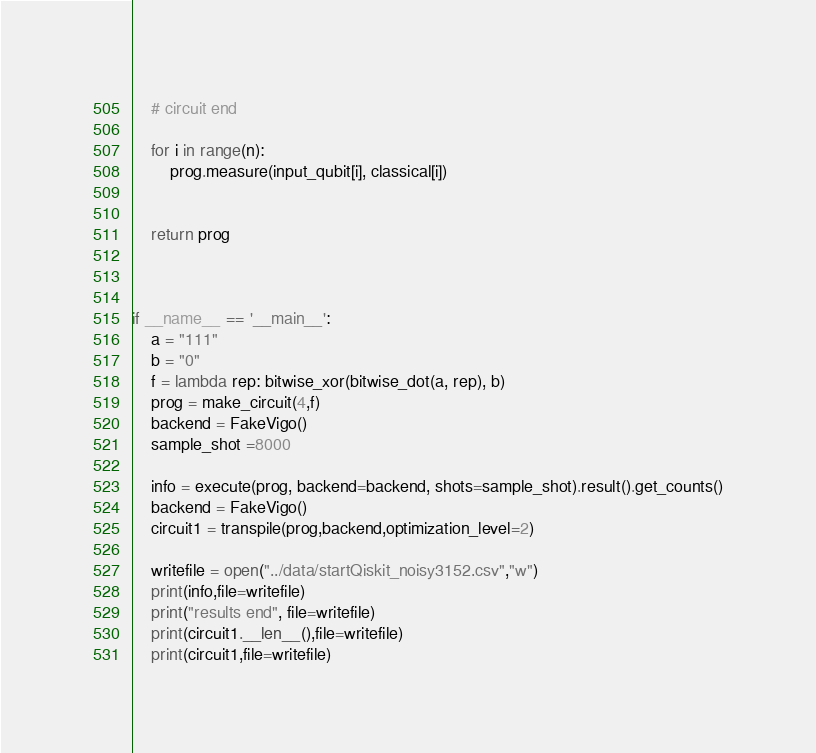Convert code to text. <code><loc_0><loc_0><loc_500><loc_500><_Python_>    # circuit end

    for i in range(n):
        prog.measure(input_qubit[i], classical[i])


    return prog



if __name__ == '__main__':
    a = "111"
    b = "0"
    f = lambda rep: bitwise_xor(bitwise_dot(a, rep), b)
    prog = make_circuit(4,f)
    backend = FakeVigo()
    sample_shot =8000

    info = execute(prog, backend=backend, shots=sample_shot).result().get_counts()
    backend = FakeVigo()
    circuit1 = transpile(prog,backend,optimization_level=2)

    writefile = open("../data/startQiskit_noisy3152.csv","w")
    print(info,file=writefile)
    print("results end", file=writefile)
    print(circuit1.__len__(),file=writefile)
    print(circuit1,file=writefile)</code> 